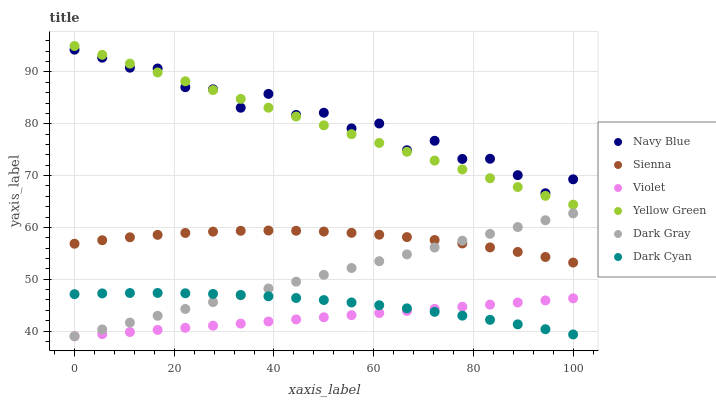Does Violet have the minimum area under the curve?
Answer yes or no. Yes. Does Navy Blue have the maximum area under the curve?
Answer yes or no. Yes. Does Yellow Green have the minimum area under the curve?
Answer yes or no. No. Does Yellow Green have the maximum area under the curve?
Answer yes or no. No. Is Dark Gray the smoothest?
Answer yes or no. Yes. Is Navy Blue the roughest?
Answer yes or no. Yes. Is Yellow Green the smoothest?
Answer yes or no. No. Is Yellow Green the roughest?
Answer yes or no. No. Does Dark Gray have the lowest value?
Answer yes or no. Yes. Does Yellow Green have the lowest value?
Answer yes or no. No. Does Yellow Green have the highest value?
Answer yes or no. Yes. Does Navy Blue have the highest value?
Answer yes or no. No. Is Dark Cyan less than Navy Blue?
Answer yes or no. Yes. Is Sienna greater than Violet?
Answer yes or no. Yes. Does Sienna intersect Dark Gray?
Answer yes or no. Yes. Is Sienna less than Dark Gray?
Answer yes or no. No. Is Sienna greater than Dark Gray?
Answer yes or no. No. Does Dark Cyan intersect Navy Blue?
Answer yes or no. No. 